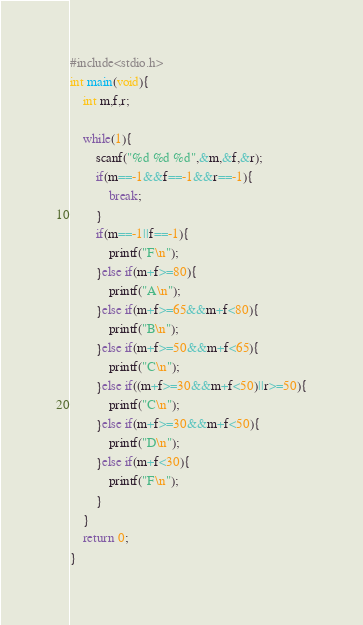<code> <loc_0><loc_0><loc_500><loc_500><_C_>#include<stdio.h>
int main(void){
	int m,f,r;
	
	while(1){
		scanf("%d %d %d",&m,&f,&r);
		if(m==-1&&f==-1&&r==-1){
			break;
		}
		if(m==-1||f==-1){
			printf("F\n");
		}else if(m+f>=80){
			printf("A\n");
		}else if(m+f>=65&&m+f<80){
			printf("B\n");
		}else if(m+f>=50&&m+f<65){
			printf("C\n");
		}else if((m+f>=30&&m+f<50)||r>=50){
			printf("C\n");
		}else if(m+f>=30&&m+f<50){
			printf("D\n");
		}else if(m+f<30){
			printf("F\n");
		}
	}
	return 0;
}</code> 